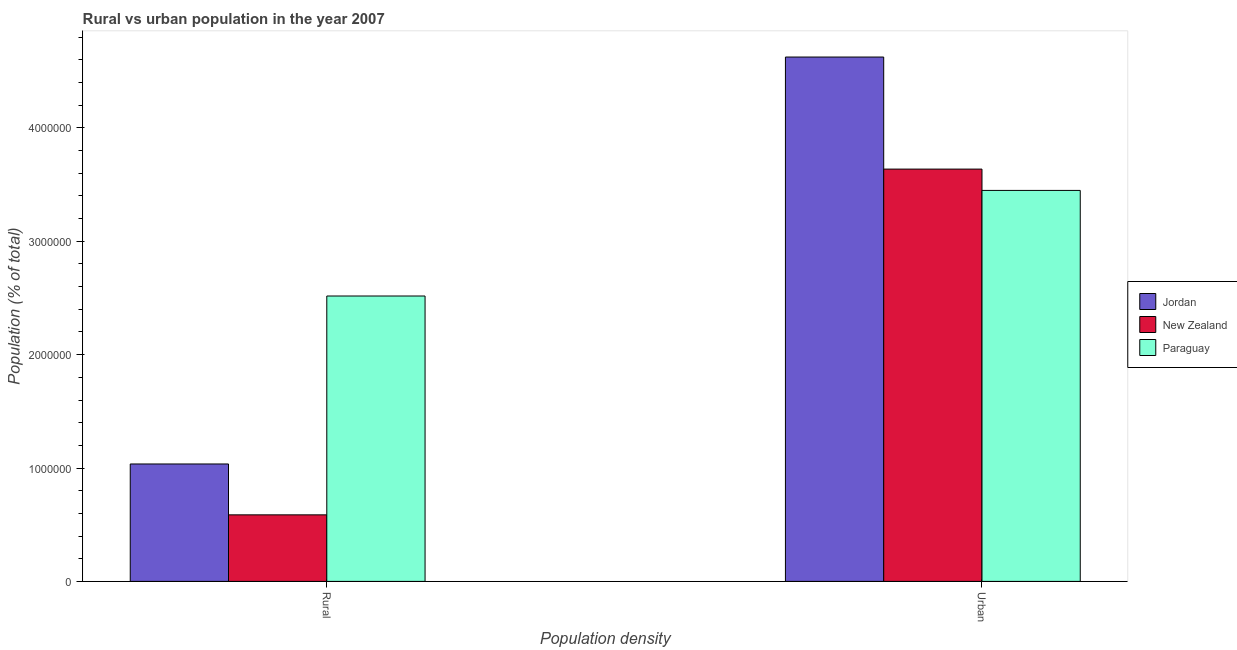How many groups of bars are there?
Offer a terse response. 2. Are the number of bars on each tick of the X-axis equal?
Give a very brief answer. Yes. How many bars are there on the 2nd tick from the right?
Offer a very short reply. 3. What is the label of the 2nd group of bars from the left?
Keep it short and to the point. Urban. What is the urban population density in New Zealand?
Keep it short and to the point. 3.64e+06. Across all countries, what is the maximum rural population density?
Offer a very short reply. 2.52e+06. Across all countries, what is the minimum urban population density?
Give a very brief answer. 3.45e+06. In which country was the urban population density maximum?
Give a very brief answer. Jordan. In which country was the urban population density minimum?
Provide a succinct answer. Paraguay. What is the total rural population density in the graph?
Your response must be concise. 4.14e+06. What is the difference between the urban population density in New Zealand and that in Paraguay?
Offer a very short reply. 1.88e+05. What is the difference between the rural population density in Jordan and the urban population density in Paraguay?
Your answer should be very brief. -2.41e+06. What is the average rural population density per country?
Provide a succinct answer. 1.38e+06. What is the difference between the rural population density and urban population density in Jordan?
Provide a short and direct response. -3.59e+06. In how many countries, is the rural population density greater than 2200000 %?
Your answer should be compact. 1. What is the ratio of the rural population density in Paraguay to that in Jordan?
Your response must be concise. 2.43. Is the urban population density in Jordan less than that in New Zealand?
Ensure brevity in your answer.  No. What does the 3rd bar from the left in Urban represents?
Provide a short and direct response. Paraguay. What does the 1st bar from the right in Rural represents?
Ensure brevity in your answer.  Paraguay. Are all the bars in the graph horizontal?
Make the answer very short. No. How many countries are there in the graph?
Provide a short and direct response. 3. What is the difference between two consecutive major ticks on the Y-axis?
Ensure brevity in your answer.  1.00e+06. Does the graph contain any zero values?
Provide a short and direct response. No. Where does the legend appear in the graph?
Make the answer very short. Center right. How many legend labels are there?
Provide a short and direct response. 3. How are the legend labels stacked?
Provide a short and direct response. Vertical. What is the title of the graph?
Keep it short and to the point. Rural vs urban population in the year 2007. Does "Niger" appear as one of the legend labels in the graph?
Your answer should be very brief. No. What is the label or title of the X-axis?
Give a very brief answer. Population density. What is the label or title of the Y-axis?
Provide a succinct answer. Population (% of total). What is the Population (% of total) of Jordan in Rural?
Ensure brevity in your answer.  1.04e+06. What is the Population (% of total) in New Zealand in Rural?
Provide a succinct answer. 5.87e+05. What is the Population (% of total) in Paraguay in Rural?
Your answer should be very brief. 2.52e+06. What is the Population (% of total) of Jordan in Urban?
Your response must be concise. 4.63e+06. What is the Population (% of total) in New Zealand in Urban?
Your answer should be compact. 3.64e+06. What is the Population (% of total) in Paraguay in Urban?
Ensure brevity in your answer.  3.45e+06. Across all Population density, what is the maximum Population (% of total) in Jordan?
Ensure brevity in your answer.  4.63e+06. Across all Population density, what is the maximum Population (% of total) of New Zealand?
Your response must be concise. 3.64e+06. Across all Population density, what is the maximum Population (% of total) in Paraguay?
Provide a succinct answer. 3.45e+06. Across all Population density, what is the minimum Population (% of total) of Jordan?
Your response must be concise. 1.04e+06. Across all Population density, what is the minimum Population (% of total) in New Zealand?
Your response must be concise. 5.87e+05. Across all Population density, what is the minimum Population (% of total) of Paraguay?
Provide a succinct answer. 2.52e+06. What is the total Population (% of total) of Jordan in the graph?
Provide a short and direct response. 5.66e+06. What is the total Population (% of total) of New Zealand in the graph?
Provide a succinct answer. 4.22e+06. What is the total Population (% of total) in Paraguay in the graph?
Ensure brevity in your answer.  5.97e+06. What is the difference between the Population (% of total) of Jordan in Rural and that in Urban?
Keep it short and to the point. -3.59e+06. What is the difference between the Population (% of total) of New Zealand in Rural and that in Urban?
Your answer should be very brief. -3.05e+06. What is the difference between the Population (% of total) in Paraguay in Rural and that in Urban?
Make the answer very short. -9.31e+05. What is the difference between the Population (% of total) of Jordan in Rural and the Population (% of total) of New Zealand in Urban?
Make the answer very short. -2.60e+06. What is the difference between the Population (% of total) of Jordan in Rural and the Population (% of total) of Paraguay in Urban?
Keep it short and to the point. -2.41e+06. What is the difference between the Population (% of total) of New Zealand in Rural and the Population (% of total) of Paraguay in Urban?
Your answer should be very brief. -2.86e+06. What is the average Population (% of total) of Jordan per Population density?
Ensure brevity in your answer.  2.83e+06. What is the average Population (% of total) of New Zealand per Population density?
Your answer should be very brief. 2.11e+06. What is the average Population (% of total) of Paraguay per Population density?
Provide a succinct answer. 2.98e+06. What is the difference between the Population (% of total) in Jordan and Population (% of total) in New Zealand in Rural?
Offer a terse response. 4.49e+05. What is the difference between the Population (% of total) of Jordan and Population (% of total) of Paraguay in Rural?
Offer a very short reply. -1.48e+06. What is the difference between the Population (% of total) in New Zealand and Population (% of total) in Paraguay in Rural?
Your answer should be very brief. -1.93e+06. What is the difference between the Population (% of total) of Jordan and Population (% of total) of New Zealand in Urban?
Offer a very short reply. 9.88e+05. What is the difference between the Population (% of total) in Jordan and Population (% of total) in Paraguay in Urban?
Keep it short and to the point. 1.18e+06. What is the difference between the Population (% of total) in New Zealand and Population (% of total) in Paraguay in Urban?
Your answer should be compact. 1.88e+05. What is the ratio of the Population (% of total) in Jordan in Rural to that in Urban?
Provide a succinct answer. 0.22. What is the ratio of the Population (% of total) of New Zealand in Rural to that in Urban?
Ensure brevity in your answer.  0.16. What is the ratio of the Population (% of total) in Paraguay in Rural to that in Urban?
Give a very brief answer. 0.73. What is the difference between the highest and the second highest Population (% of total) of Jordan?
Ensure brevity in your answer.  3.59e+06. What is the difference between the highest and the second highest Population (% of total) in New Zealand?
Your answer should be compact. 3.05e+06. What is the difference between the highest and the second highest Population (% of total) in Paraguay?
Provide a succinct answer. 9.31e+05. What is the difference between the highest and the lowest Population (% of total) in Jordan?
Keep it short and to the point. 3.59e+06. What is the difference between the highest and the lowest Population (% of total) in New Zealand?
Keep it short and to the point. 3.05e+06. What is the difference between the highest and the lowest Population (% of total) in Paraguay?
Give a very brief answer. 9.31e+05. 